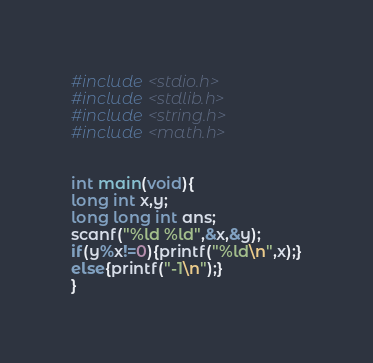<code> <loc_0><loc_0><loc_500><loc_500><_C_>#include <stdio.h>
#include <stdlib.h>
#include <string.h>
#include <math.h>
 
 
int main(void){
long int x,y;
long long int ans;
scanf("%ld %ld",&x,&y);
if(y%x!=0){printf("%ld\n",x);}
else{printf("-1\n");}
}</code> 